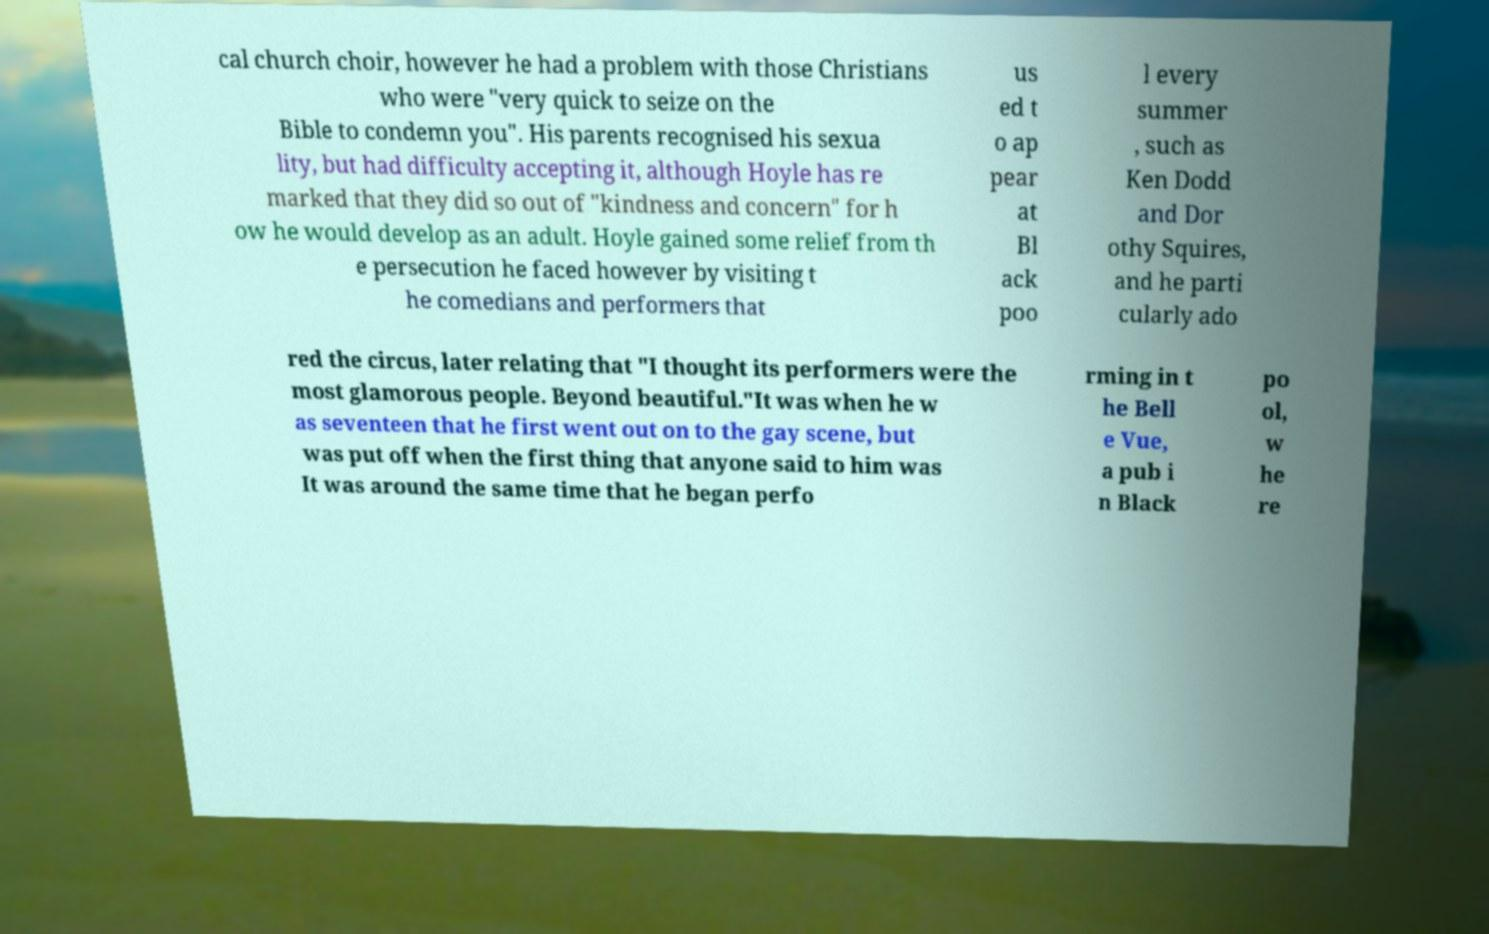Please read and relay the text visible in this image. What does it say? cal church choir, however he had a problem with those Christians who were "very quick to seize on the Bible to condemn you". His parents recognised his sexua lity, but had difficulty accepting it, although Hoyle has re marked that they did so out of "kindness and concern" for h ow he would develop as an adult. Hoyle gained some relief from th e persecution he faced however by visiting t he comedians and performers that us ed t o ap pear at Bl ack poo l every summer , such as Ken Dodd and Dor othy Squires, and he parti cularly ado red the circus, later relating that "I thought its performers were the most glamorous people. Beyond beautiful."It was when he w as seventeen that he first went out on to the gay scene, but was put off when the first thing that anyone said to him was It was around the same time that he began perfo rming in t he Bell e Vue, a pub i n Black po ol, w he re 